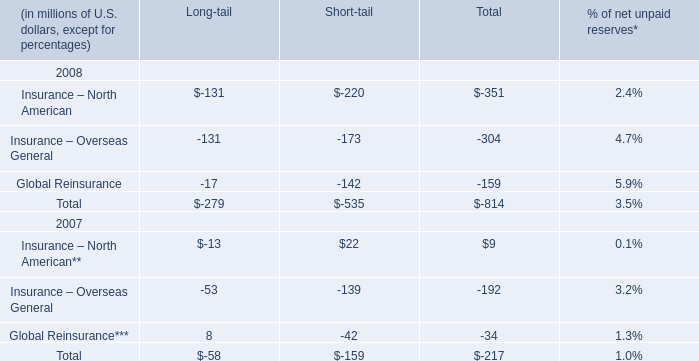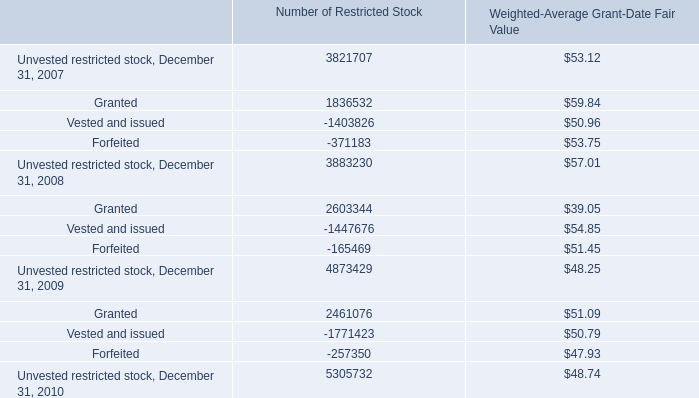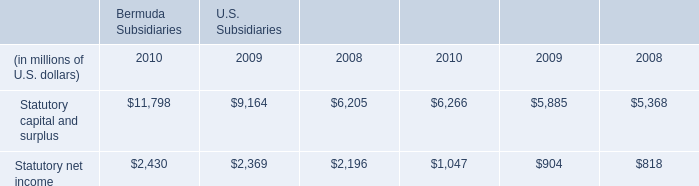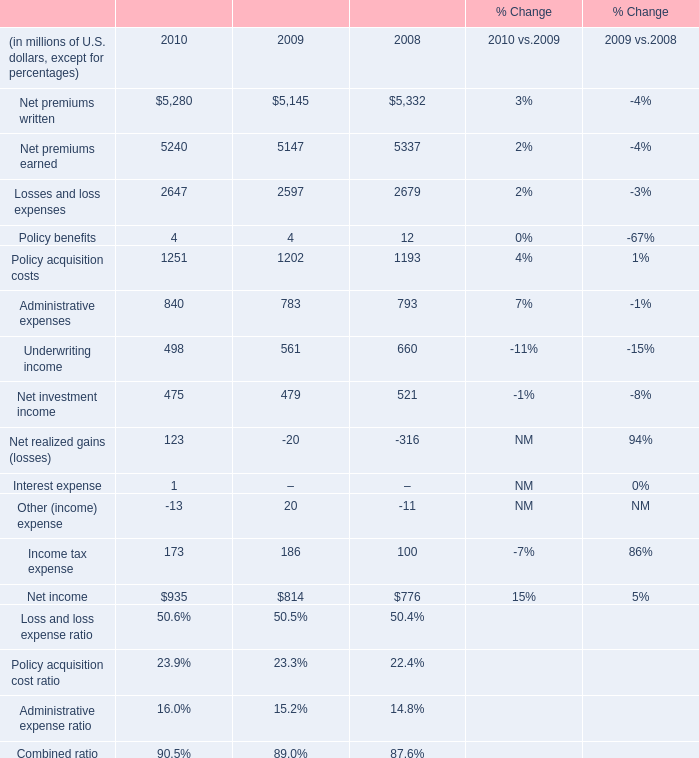what was the average potential anti-dilutive share conversions from 2008 to 2010 
Computations: (((638401 + (256868 + 1230881)) + 3) / 2)
Answer: 1063076.5. 